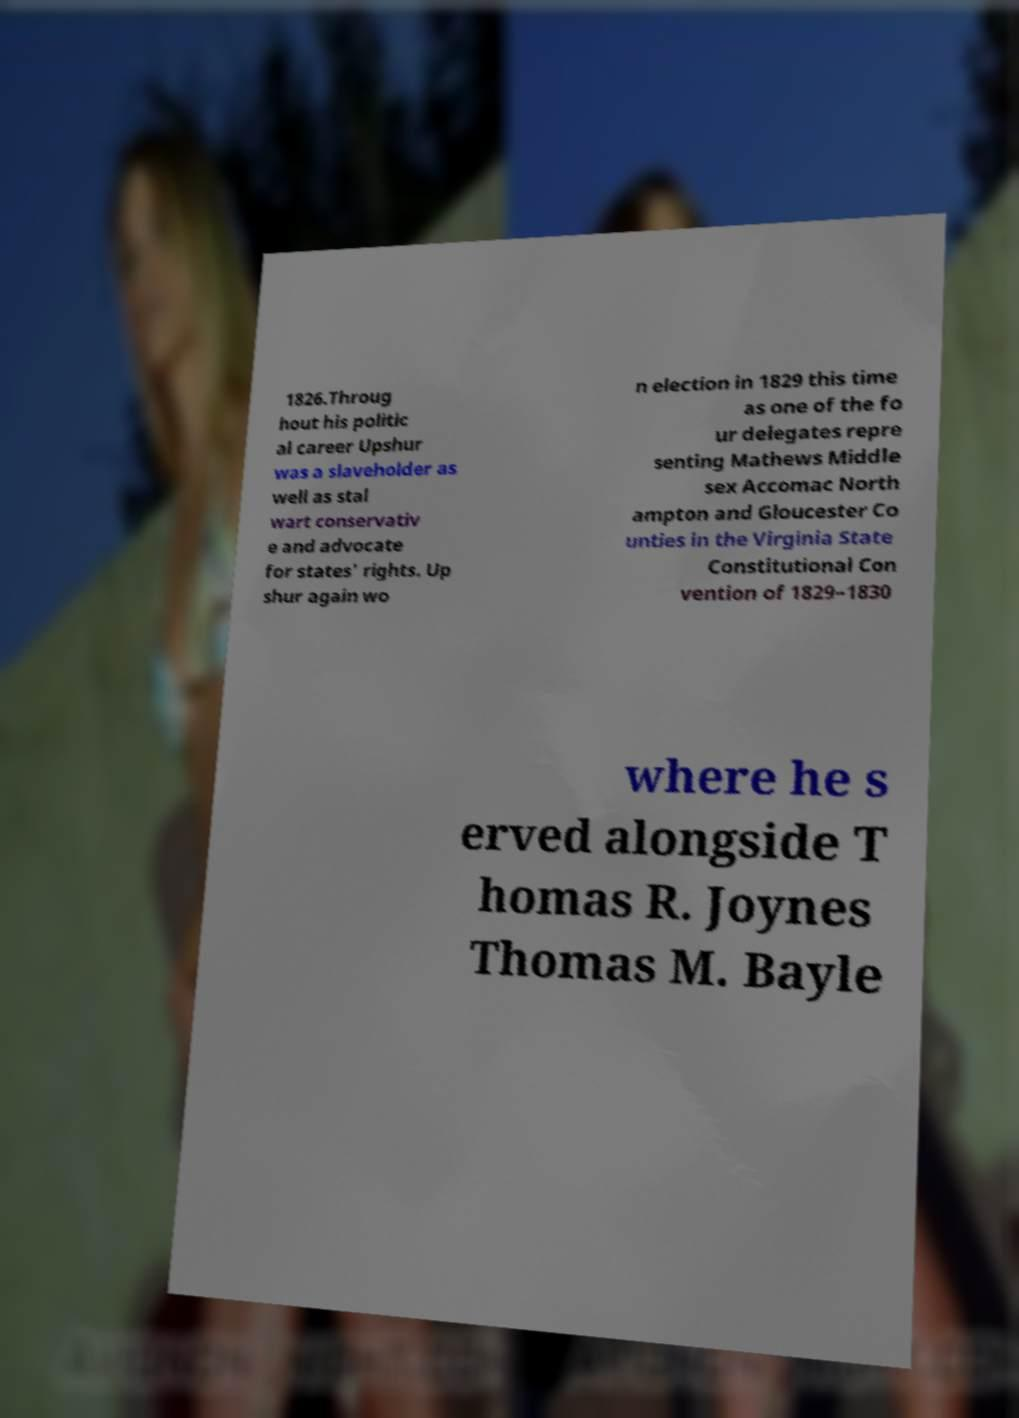Can you read and provide the text displayed in the image?This photo seems to have some interesting text. Can you extract and type it out for me? 1826.Throug hout his politic al career Upshur was a slaveholder as well as stal wart conservativ e and advocate for states' rights. Up shur again wo n election in 1829 this time as one of the fo ur delegates repre senting Mathews Middle sex Accomac North ampton and Gloucester Co unties in the Virginia State Constitutional Con vention of 1829–1830 where he s erved alongside T homas R. Joynes Thomas M. Bayle 